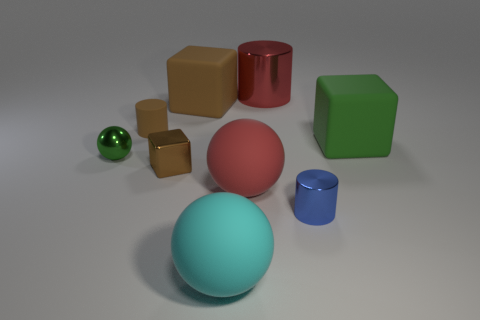Add 1 tiny cubes. How many objects exist? 10 Subtract all cubes. How many objects are left? 6 Add 2 gray matte cylinders. How many gray matte cylinders exist? 2 Subtract 1 brown cylinders. How many objects are left? 8 Subtract all tiny brown metallic objects. Subtract all green shiny things. How many objects are left? 7 Add 8 large cyan things. How many large cyan things are left? 9 